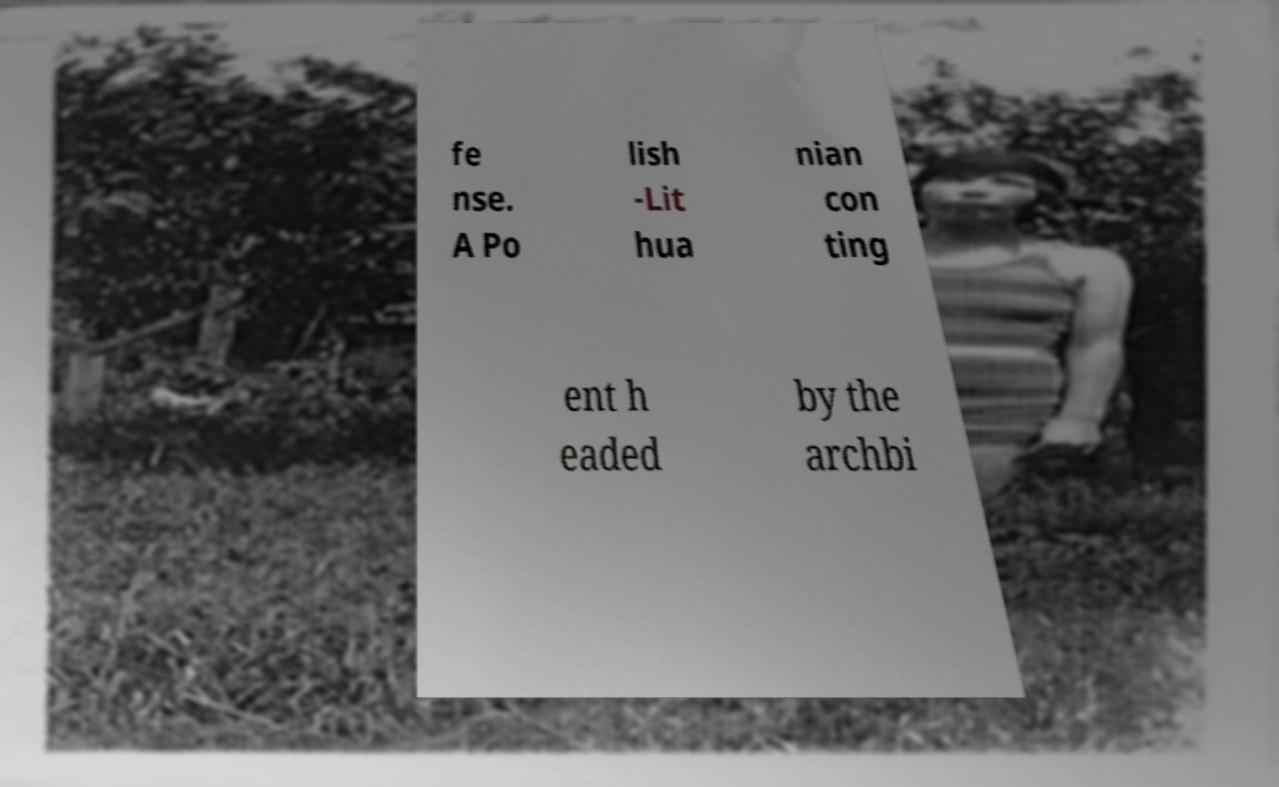For documentation purposes, I need the text within this image transcribed. Could you provide that? fe nse. A Po lish -Lit hua nian con ting ent h eaded by the archbi 